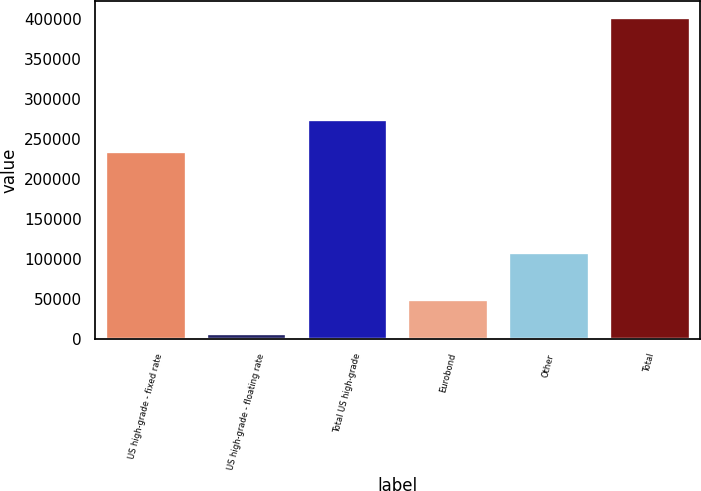Convert chart to OTSL. <chart><loc_0><loc_0><loc_500><loc_500><bar_chart><fcel>US high-grade - fixed rate<fcel>US high-grade - floating rate<fcel>Total US high-grade<fcel>Eurobond<fcel>Other<fcel>Total<nl><fcel>235698<fcel>7698<fcel>275154<fcel>50251<fcel>108610<fcel>402257<nl></chart> 